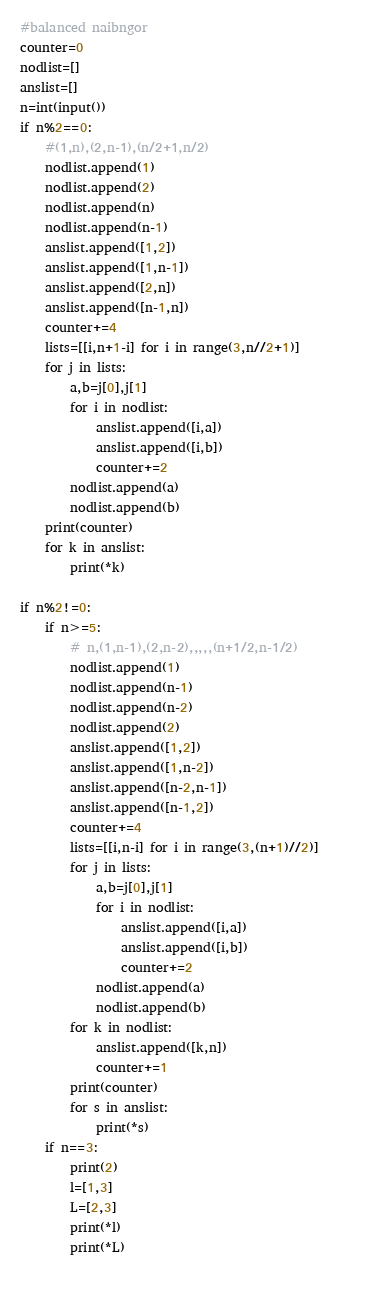Convert code to text. <code><loc_0><loc_0><loc_500><loc_500><_Python_>#balanced naibngor
counter=0
nodlist=[]
anslist=[]
n=int(input())
if n%2==0:
    #(1,n),(2,n-1),(n/2+1,n/2)
    nodlist.append(1)
    nodlist.append(2)
    nodlist.append(n)
    nodlist.append(n-1)
    anslist.append([1,2])
    anslist.append([1,n-1])
    anslist.append([2,n])
    anslist.append([n-1,n])
    counter+=4
    lists=[[i,n+1-i] for i in range(3,n//2+1)]
    for j in lists:
        a,b=j[0],j[1]
        for i in nodlist:
            anslist.append([i,a])
            anslist.append([i,b])
            counter+=2
        nodlist.append(a)
        nodlist.append(b)
    print(counter)
    for k in anslist:
        print(*k)

if n%2!=0:
    if n>=5:
        # n,(1,n-1),(2,n-2),,,,,(n+1/2,n-1/2)
        nodlist.append(1)
        nodlist.append(n-1)
        nodlist.append(n-2)
        nodlist.append(2)
        anslist.append([1,2])
        anslist.append([1,n-2])
        anslist.append([n-2,n-1])
        anslist.append([n-1,2])
        counter+=4
        lists=[[i,n-i] for i in range(3,(n+1)//2)]        
        for j in lists:
            a,b=j[0],j[1]
            for i in nodlist:
                anslist.append([i,a])
                anslist.append([i,b])
                counter+=2
            nodlist.append(a)
            nodlist.append(b)  
        for k in nodlist:
            anslist.append([k,n])
            counter+=1
        print(counter)
        for s in anslist:
            print(*s)
    if n==3:
        print(2)
        l=[1,3]
        L=[2,3]
        print(*l)
        print(*L)
    </code> 